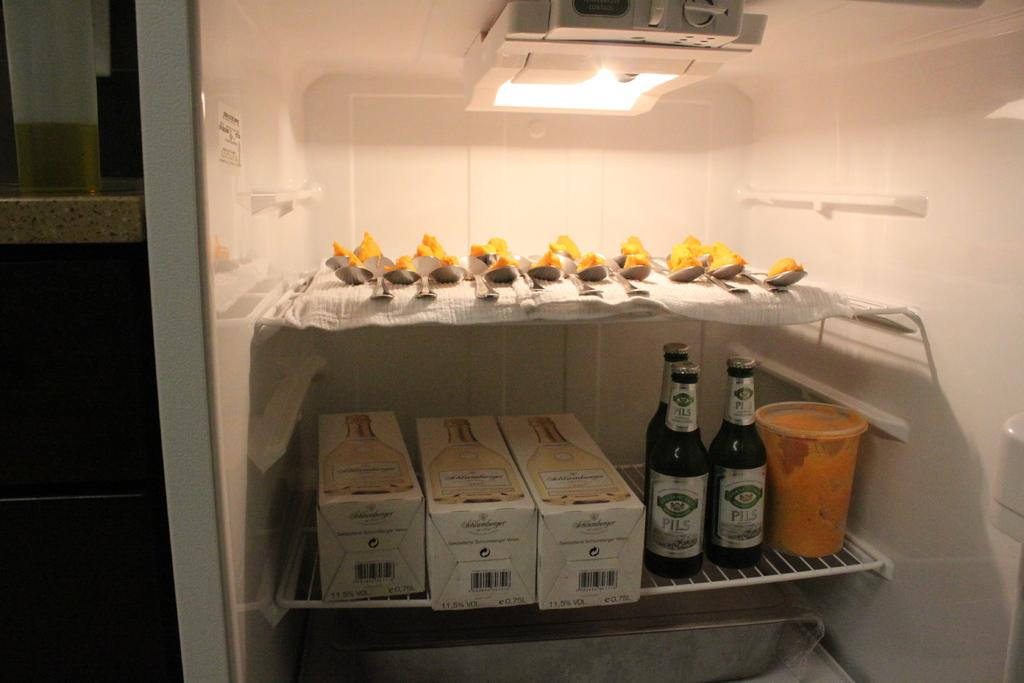What type of containers can be seen in the image? There are boxes and bottles in the image. What utensils are present in the image? There are spoons in the image. What material is covering the shelves in the image? There is a cloth in the image, likely covering the shelves. What is used to hold food items in the image? There is a bowl in the image. What source of illumination is visible in the image? There is a light in the image. What type of food items can be seen in the image? There are food items in the image. Can you see any cups floating on the lake in the image? There is no lake or cups present in the image; it is a refrigerator containing various objects. What type of plate is being used to serve the food in the image? There is no plate visible in the image; the food items are stored in boxes, bottles, and a bowl. 